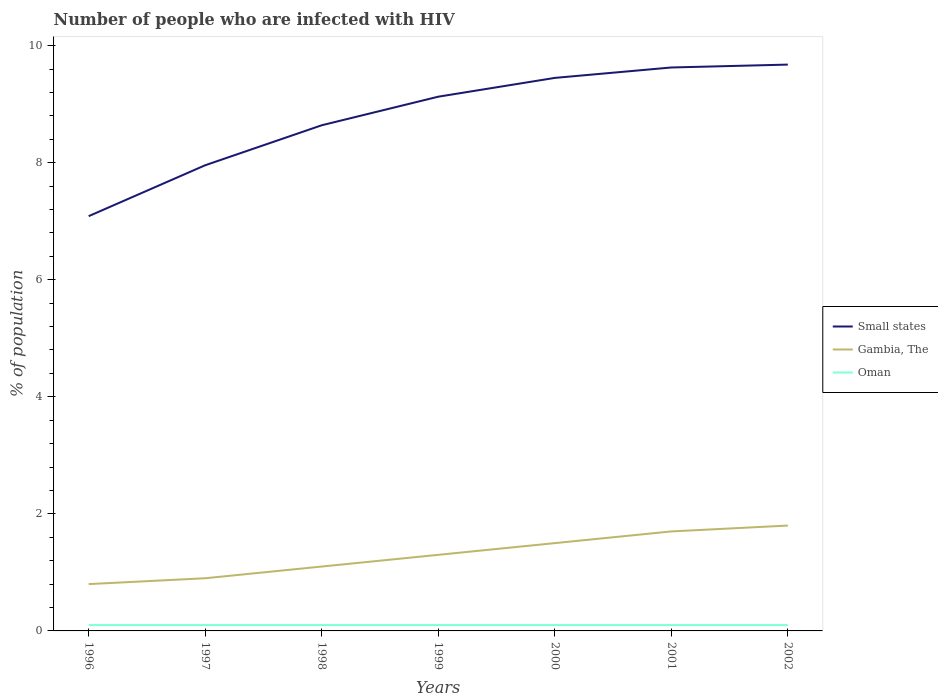Is the number of lines equal to the number of legend labels?
Provide a succinct answer. Yes. In which year was the percentage of HIV infected population in in Oman maximum?
Provide a short and direct response. 1996. What is the total percentage of HIV infected population in in Small states in the graph?
Offer a terse response. -0.5. What is the difference between the highest and the second highest percentage of HIV infected population in in Small states?
Provide a short and direct response. 2.59. Is the percentage of HIV infected population in in Small states strictly greater than the percentage of HIV infected population in in Gambia, The over the years?
Keep it short and to the point. No. How many years are there in the graph?
Your answer should be compact. 7. Are the values on the major ticks of Y-axis written in scientific E-notation?
Ensure brevity in your answer.  No. How many legend labels are there?
Make the answer very short. 3. How are the legend labels stacked?
Your answer should be very brief. Vertical. What is the title of the graph?
Your response must be concise. Number of people who are infected with HIV. Does "Egypt, Arab Rep." appear as one of the legend labels in the graph?
Provide a short and direct response. No. What is the label or title of the X-axis?
Offer a very short reply. Years. What is the label or title of the Y-axis?
Provide a succinct answer. % of population. What is the % of population of Small states in 1996?
Offer a very short reply. 7.09. What is the % of population of Small states in 1997?
Keep it short and to the point. 7.96. What is the % of population in Gambia, The in 1997?
Ensure brevity in your answer.  0.9. What is the % of population in Oman in 1997?
Keep it short and to the point. 0.1. What is the % of population in Small states in 1998?
Your answer should be compact. 8.64. What is the % of population in Gambia, The in 1998?
Ensure brevity in your answer.  1.1. What is the % of population of Oman in 1998?
Keep it short and to the point. 0.1. What is the % of population in Small states in 1999?
Your response must be concise. 9.13. What is the % of population in Oman in 1999?
Give a very brief answer. 0.1. What is the % of population in Small states in 2000?
Offer a terse response. 9.45. What is the % of population of Gambia, The in 2000?
Keep it short and to the point. 1.5. What is the % of population of Oman in 2000?
Provide a succinct answer. 0.1. What is the % of population of Small states in 2001?
Make the answer very short. 9.63. What is the % of population of Small states in 2002?
Keep it short and to the point. 9.68. What is the % of population in Gambia, The in 2002?
Provide a succinct answer. 1.8. Across all years, what is the maximum % of population of Small states?
Offer a very short reply. 9.68. Across all years, what is the maximum % of population in Gambia, The?
Make the answer very short. 1.8. Across all years, what is the maximum % of population in Oman?
Make the answer very short. 0.1. Across all years, what is the minimum % of population of Small states?
Make the answer very short. 7.09. Across all years, what is the minimum % of population of Gambia, The?
Ensure brevity in your answer.  0.8. What is the total % of population of Small states in the graph?
Your answer should be very brief. 61.56. What is the difference between the % of population in Small states in 1996 and that in 1997?
Keep it short and to the point. -0.87. What is the difference between the % of population of Small states in 1996 and that in 1998?
Make the answer very short. -1.55. What is the difference between the % of population of Gambia, The in 1996 and that in 1998?
Provide a short and direct response. -0.3. What is the difference between the % of population of Oman in 1996 and that in 1998?
Your response must be concise. 0. What is the difference between the % of population of Small states in 1996 and that in 1999?
Ensure brevity in your answer.  -2.04. What is the difference between the % of population in Gambia, The in 1996 and that in 1999?
Ensure brevity in your answer.  -0.5. What is the difference between the % of population in Oman in 1996 and that in 1999?
Your answer should be compact. 0. What is the difference between the % of population of Small states in 1996 and that in 2000?
Keep it short and to the point. -2.36. What is the difference between the % of population in Small states in 1996 and that in 2001?
Offer a very short reply. -2.54. What is the difference between the % of population in Small states in 1996 and that in 2002?
Provide a succinct answer. -2.59. What is the difference between the % of population of Gambia, The in 1996 and that in 2002?
Your response must be concise. -1. What is the difference between the % of population in Oman in 1996 and that in 2002?
Ensure brevity in your answer.  0. What is the difference between the % of population in Small states in 1997 and that in 1998?
Your response must be concise. -0.68. What is the difference between the % of population in Small states in 1997 and that in 1999?
Ensure brevity in your answer.  -1.17. What is the difference between the % of population of Gambia, The in 1997 and that in 1999?
Make the answer very short. -0.4. What is the difference between the % of population in Small states in 1997 and that in 2000?
Provide a succinct answer. -1.49. What is the difference between the % of population of Gambia, The in 1997 and that in 2000?
Offer a very short reply. -0.6. What is the difference between the % of population of Small states in 1997 and that in 2001?
Offer a terse response. -1.67. What is the difference between the % of population in Gambia, The in 1997 and that in 2001?
Your response must be concise. -0.8. What is the difference between the % of population in Oman in 1997 and that in 2001?
Provide a short and direct response. 0. What is the difference between the % of population in Small states in 1997 and that in 2002?
Provide a short and direct response. -1.72. What is the difference between the % of population of Oman in 1997 and that in 2002?
Your answer should be very brief. 0. What is the difference between the % of population of Small states in 1998 and that in 1999?
Your answer should be very brief. -0.49. What is the difference between the % of population of Small states in 1998 and that in 2000?
Provide a succinct answer. -0.81. What is the difference between the % of population in Gambia, The in 1998 and that in 2000?
Ensure brevity in your answer.  -0.4. What is the difference between the % of population in Oman in 1998 and that in 2000?
Offer a terse response. 0. What is the difference between the % of population in Small states in 1998 and that in 2001?
Your response must be concise. -0.99. What is the difference between the % of population in Small states in 1998 and that in 2002?
Offer a terse response. -1.04. What is the difference between the % of population of Small states in 1999 and that in 2000?
Your answer should be very brief. -0.32. What is the difference between the % of population in Gambia, The in 1999 and that in 2000?
Give a very brief answer. -0.2. What is the difference between the % of population of Small states in 1999 and that in 2001?
Provide a succinct answer. -0.5. What is the difference between the % of population of Oman in 1999 and that in 2001?
Make the answer very short. 0. What is the difference between the % of population of Small states in 1999 and that in 2002?
Give a very brief answer. -0.55. What is the difference between the % of population of Small states in 2000 and that in 2001?
Offer a terse response. -0.18. What is the difference between the % of population in Gambia, The in 2000 and that in 2001?
Ensure brevity in your answer.  -0.2. What is the difference between the % of population in Oman in 2000 and that in 2001?
Provide a succinct answer. 0. What is the difference between the % of population of Small states in 2000 and that in 2002?
Ensure brevity in your answer.  -0.23. What is the difference between the % of population of Gambia, The in 2000 and that in 2002?
Make the answer very short. -0.3. What is the difference between the % of population of Small states in 2001 and that in 2002?
Your answer should be compact. -0.05. What is the difference between the % of population of Gambia, The in 2001 and that in 2002?
Provide a short and direct response. -0.1. What is the difference between the % of population of Oman in 2001 and that in 2002?
Your response must be concise. 0. What is the difference between the % of population in Small states in 1996 and the % of population in Gambia, The in 1997?
Make the answer very short. 6.19. What is the difference between the % of population in Small states in 1996 and the % of population in Oman in 1997?
Your response must be concise. 6.99. What is the difference between the % of population in Gambia, The in 1996 and the % of population in Oman in 1997?
Give a very brief answer. 0.7. What is the difference between the % of population in Small states in 1996 and the % of population in Gambia, The in 1998?
Make the answer very short. 5.99. What is the difference between the % of population in Small states in 1996 and the % of population in Oman in 1998?
Your answer should be very brief. 6.99. What is the difference between the % of population in Small states in 1996 and the % of population in Gambia, The in 1999?
Keep it short and to the point. 5.79. What is the difference between the % of population in Small states in 1996 and the % of population in Oman in 1999?
Offer a terse response. 6.99. What is the difference between the % of population of Small states in 1996 and the % of population of Gambia, The in 2000?
Give a very brief answer. 5.59. What is the difference between the % of population in Small states in 1996 and the % of population in Oman in 2000?
Your response must be concise. 6.99. What is the difference between the % of population of Small states in 1996 and the % of population of Gambia, The in 2001?
Provide a succinct answer. 5.39. What is the difference between the % of population of Small states in 1996 and the % of population of Oman in 2001?
Give a very brief answer. 6.99. What is the difference between the % of population in Small states in 1996 and the % of population in Gambia, The in 2002?
Keep it short and to the point. 5.29. What is the difference between the % of population in Small states in 1996 and the % of population in Oman in 2002?
Provide a succinct answer. 6.99. What is the difference between the % of population in Small states in 1997 and the % of population in Gambia, The in 1998?
Keep it short and to the point. 6.86. What is the difference between the % of population in Small states in 1997 and the % of population in Oman in 1998?
Your answer should be compact. 7.86. What is the difference between the % of population in Small states in 1997 and the % of population in Gambia, The in 1999?
Give a very brief answer. 6.66. What is the difference between the % of population of Small states in 1997 and the % of population of Oman in 1999?
Your answer should be compact. 7.86. What is the difference between the % of population in Gambia, The in 1997 and the % of population in Oman in 1999?
Provide a short and direct response. 0.8. What is the difference between the % of population of Small states in 1997 and the % of population of Gambia, The in 2000?
Offer a very short reply. 6.46. What is the difference between the % of population in Small states in 1997 and the % of population in Oman in 2000?
Your answer should be compact. 7.86. What is the difference between the % of population in Small states in 1997 and the % of population in Gambia, The in 2001?
Your answer should be compact. 6.26. What is the difference between the % of population in Small states in 1997 and the % of population in Oman in 2001?
Provide a short and direct response. 7.86. What is the difference between the % of population in Gambia, The in 1997 and the % of population in Oman in 2001?
Make the answer very short. 0.8. What is the difference between the % of population in Small states in 1997 and the % of population in Gambia, The in 2002?
Your response must be concise. 6.16. What is the difference between the % of population in Small states in 1997 and the % of population in Oman in 2002?
Your response must be concise. 7.86. What is the difference between the % of population of Small states in 1998 and the % of population of Gambia, The in 1999?
Your response must be concise. 7.34. What is the difference between the % of population of Small states in 1998 and the % of population of Oman in 1999?
Offer a very short reply. 8.54. What is the difference between the % of population of Small states in 1998 and the % of population of Gambia, The in 2000?
Your response must be concise. 7.14. What is the difference between the % of population in Small states in 1998 and the % of population in Oman in 2000?
Your response must be concise. 8.54. What is the difference between the % of population in Small states in 1998 and the % of population in Gambia, The in 2001?
Offer a terse response. 6.94. What is the difference between the % of population in Small states in 1998 and the % of population in Oman in 2001?
Your response must be concise. 8.54. What is the difference between the % of population in Small states in 1998 and the % of population in Gambia, The in 2002?
Provide a succinct answer. 6.84. What is the difference between the % of population in Small states in 1998 and the % of population in Oman in 2002?
Offer a very short reply. 8.54. What is the difference between the % of population of Gambia, The in 1998 and the % of population of Oman in 2002?
Your answer should be very brief. 1. What is the difference between the % of population in Small states in 1999 and the % of population in Gambia, The in 2000?
Your answer should be compact. 7.63. What is the difference between the % of population in Small states in 1999 and the % of population in Oman in 2000?
Your response must be concise. 9.03. What is the difference between the % of population in Small states in 1999 and the % of population in Gambia, The in 2001?
Keep it short and to the point. 7.43. What is the difference between the % of population of Small states in 1999 and the % of population of Oman in 2001?
Your answer should be compact. 9.03. What is the difference between the % of population in Small states in 1999 and the % of population in Gambia, The in 2002?
Offer a terse response. 7.33. What is the difference between the % of population of Small states in 1999 and the % of population of Oman in 2002?
Your response must be concise. 9.03. What is the difference between the % of population of Small states in 2000 and the % of population of Gambia, The in 2001?
Give a very brief answer. 7.75. What is the difference between the % of population of Small states in 2000 and the % of population of Oman in 2001?
Offer a very short reply. 9.35. What is the difference between the % of population in Small states in 2000 and the % of population in Gambia, The in 2002?
Your response must be concise. 7.65. What is the difference between the % of population of Small states in 2000 and the % of population of Oman in 2002?
Provide a short and direct response. 9.35. What is the difference between the % of population of Gambia, The in 2000 and the % of population of Oman in 2002?
Ensure brevity in your answer.  1.4. What is the difference between the % of population in Small states in 2001 and the % of population in Gambia, The in 2002?
Offer a very short reply. 7.83. What is the difference between the % of population in Small states in 2001 and the % of population in Oman in 2002?
Provide a succinct answer. 9.53. What is the average % of population of Small states per year?
Keep it short and to the point. 8.79. What is the average % of population of Gambia, The per year?
Make the answer very short. 1.3. In the year 1996, what is the difference between the % of population in Small states and % of population in Gambia, The?
Keep it short and to the point. 6.29. In the year 1996, what is the difference between the % of population of Small states and % of population of Oman?
Offer a terse response. 6.99. In the year 1996, what is the difference between the % of population of Gambia, The and % of population of Oman?
Provide a succinct answer. 0.7. In the year 1997, what is the difference between the % of population of Small states and % of population of Gambia, The?
Make the answer very short. 7.06. In the year 1997, what is the difference between the % of population of Small states and % of population of Oman?
Make the answer very short. 7.86. In the year 1998, what is the difference between the % of population in Small states and % of population in Gambia, The?
Offer a very short reply. 7.54. In the year 1998, what is the difference between the % of population of Small states and % of population of Oman?
Offer a very short reply. 8.54. In the year 1999, what is the difference between the % of population of Small states and % of population of Gambia, The?
Provide a short and direct response. 7.83. In the year 1999, what is the difference between the % of population of Small states and % of population of Oman?
Provide a succinct answer. 9.03. In the year 1999, what is the difference between the % of population in Gambia, The and % of population in Oman?
Your response must be concise. 1.2. In the year 2000, what is the difference between the % of population of Small states and % of population of Gambia, The?
Provide a short and direct response. 7.95. In the year 2000, what is the difference between the % of population in Small states and % of population in Oman?
Offer a very short reply. 9.35. In the year 2001, what is the difference between the % of population of Small states and % of population of Gambia, The?
Give a very brief answer. 7.93. In the year 2001, what is the difference between the % of population of Small states and % of population of Oman?
Give a very brief answer. 9.53. In the year 2002, what is the difference between the % of population in Small states and % of population in Gambia, The?
Your answer should be very brief. 7.88. In the year 2002, what is the difference between the % of population of Small states and % of population of Oman?
Your answer should be compact. 9.58. What is the ratio of the % of population of Small states in 1996 to that in 1997?
Provide a succinct answer. 0.89. What is the ratio of the % of population in Oman in 1996 to that in 1997?
Your answer should be very brief. 1. What is the ratio of the % of population of Small states in 1996 to that in 1998?
Offer a very short reply. 0.82. What is the ratio of the % of population in Gambia, The in 1996 to that in 1998?
Your answer should be compact. 0.73. What is the ratio of the % of population of Small states in 1996 to that in 1999?
Keep it short and to the point. 0.78. What is the ratio of the % of population of Gambia, The in 1996 to that in 1999?
Ensure brevity in your answer.  0.62. What is the ratio of the % of population of Oman in 1996 to that in 1999?
Your answer should be very brief. 1. What is the ratio of the % of population of Gambia, The in 1996 to that in 2000?
Your response must be concise. 0.53. What is the ratio of the % of population in Oman in 1996 to that in 2000?
Give a very brief answer. 1. What is the ratio of the % of population of Small states in 1996 to that in 2001?
Provide a short and direct response. 0.74. What is the ratio of the % of population in Gambia, The in 1996 to that in 2001?
Your answer should be very brief. 0.47. What is the ratio of the % of population in Oman in 1996 to that in 2001?
Provide a succinct answer. 1. What is the ratio of the % of population in Small states in 1996 to that in 2002?
Provide a succinct answer. 0.73. What is the ratio of the % of population in Gambia, The in 1996 to that in 2002?
Your response must be concise. 0.44. What is the ratio of the % of population in Oman in 1996 to that in 2002?
Give a very brief answer. 1. What is the ratio of the % of population in Small states in 1997 to that in 1998?
Your answer should be compact. 0.92. What is the ratio of the % of population of Gambia, The in 1997 to that in 1998?
Keep it short and to the point. 0.82. What is the ratio of the % of population of Small states in 1997 to that in 1999?
Offer a terse response. 0.87. What is the ratio of the % of population of Gambia, The in 1997 to that in 1999?
Your response must be concise. 0.69. What is the ratio of the % of population of Oman in 1997 to that in 1999?
Your answer should be very brief. 1. What is the ratio of the % of population in Small states in 1997 to that in 2000?
Your response must be concise. 0.84. What is the ratio of the % of population in Oman in 1997 to that in 2000?
Provide a succinct answer. 1. What is the ratio of the % of population of Small states in 1997 to that in 2001?
Give a very brief answer. 0.83. What is the ratio of the % of population of Gambia, The in 1997 to that in 2001?
Keep it short and to the point. 0.53. What is the ratio of the % of population of Oman in 1997 to that in 2001?
Your response must be concise. 1. What is the ratio of the % of population of Small states in 1997 to that in 2002?
Provide a succinct answer. 0.82. What is the ratio of the % of population in Gambia, The in 1997 to that in 2002?
Your response must be concise. 0.5. What is the ratio of the % of population of Oman in 1997 to that in 2002?
Provide a succinct answer. 1. What is the ratio of the % of population of Small states in 1998 to that in 1999?
Keep it short and to the point. 0.95. What is the ratio of the % of population of Gambia, The in 1998 to that in 1999?
Your response must be concise. 0.85. What is the ratio of the % of population in Small states in 1998 to that in 2000?
Ensure brevity in your answer.  0.91. What is the ratio of the % of population of Gambia, The in 1998 to that in 2000?
Your answer should be very brief. 0.73. What is the ratio of the % of population of Small states in 1998 to that in 2001?
Keep it short and to the point. 0.9. What is the ratio of the % of population in Gambia, The in 1998 to that in 2001?
Offer a terse response. 0.65. What is the ratio of the % of population in Small states in 1998 to that in 2002?
Make the answer very short. 0.89. What is the ratio of the % of population of Gambia, The in 1998 to that in 2002?
Give a very brief answer. 0.61. What is the ratio of the % of population in Oman in 1998 to that in 2002?
Provide a short and direct response. 1. What is the ratio of the % of population in Small states in 1999 to that in 2000?
Ensure brevity in your answer.  0.97. What is the ratio of the % of population of Gambia, The in 1999 to that in 2000?
Offer a terse response. 0.87. What is the ratio of the % of population of Small states in 1999 to that in 2001?
Make the answer very short. 0.95. What is the ratio of the % of population of Gambia, The in 1999 to that in 2001?
Give a very brief answer. 0.76. What is the ratio of the % of population of Oman in 1999 to that in 2001?
Offer a terse response. 1. What is the ratio of the % of population in Small states in 1999 to that in 2002?
Provide a short and direct response. 0.94. What is the ratio of the % of population in Gambia, The in 1999 to that in 2002?
Ensure brevity in your answer.  0.72. What is the ratio of the % of population of Small states in 2000 to that in 2001?
Provide a short and direct response. 0.98. What is the ratio of the % of population of Gambia, The in 2000 to that in 2001?
Your response must be concise. 0.88. What is the ratio of the % of population of Small states in 2000 to that in 2002?
Your answer should be compact. 0.98. What is the ratio of the % of population in Gambia, The in 2000 to that in 2002?
Provide a short and direct response. 0.83. What is the ratio of the % of population of Small states in 2001 to that in 2002?
Your answer should be very brief. 0.99. What is the ratio of the % of population in Oman in 2001 to that in 2002?
Your response must be concise. 1. What is the difference between the highest and the second highest % of population in Small states?
Keep it short and to the point. 0.05. What is the difference between the highest and the second highest % of population in Oman?
Your response must be concise. 0. What is the difference between the highest and the lowest % of population in Small states?
Provide a short and direct response. 2.59. What is the difference between the highest and the lowest % of population in Gambia, The?
Offer a very short reply. 1. What is the difference between the highest and the lowest % of population of Oman?
Make the answer very short. 0. 